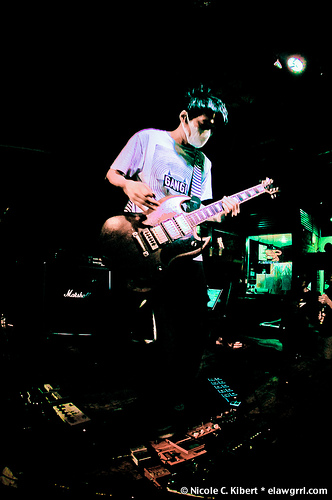<image>
Is there a man in front of the guitar? No. The man is not in front of the guitar. The spatial positioning shows a different relationship between these objects. 